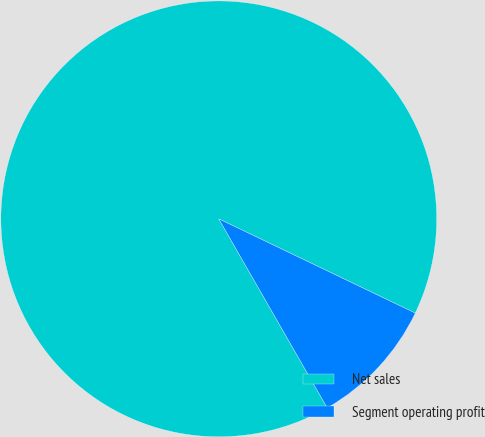<chart> <loc_0><loc_0><loc_500><loc_500><pie_chart><fcel>Net sales<fcel>Segment operating profit<nl><fcel>90.41%<fcel>9.59%<nl></chart> 